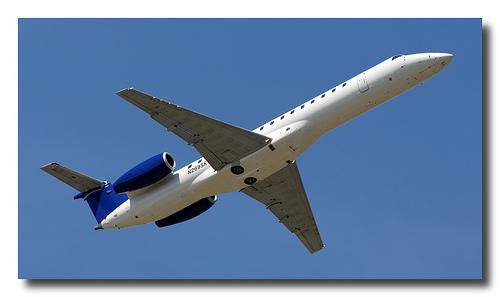Question: what color is the plane?
Choices:
A. Red.
B. Blue.
C. White.
D. Black.
Answer with the letter. Answer: C Question: what color are the plane engines?
Choices:
A. Silver.
B. Black.
C. Brown.
D. Blue.
Answer with the letter. Answer: D Question: why is the photo illuminated?
Choices:
A. The flash was on.
B. The reflection.
C. The kitchen light.
D. Sunlight.
Answer with the letter. Answer: D Question: how many planes are there?
Choices:
A. One.
B. Two.
C. Three.
D. Four.
Answer with the letter. Answer: A Question: when was this photo taken?
Choices:
A. At night.
B. In the morning.
C. Dawn.
D. During the day.
Answer with the letter. Answer: D 